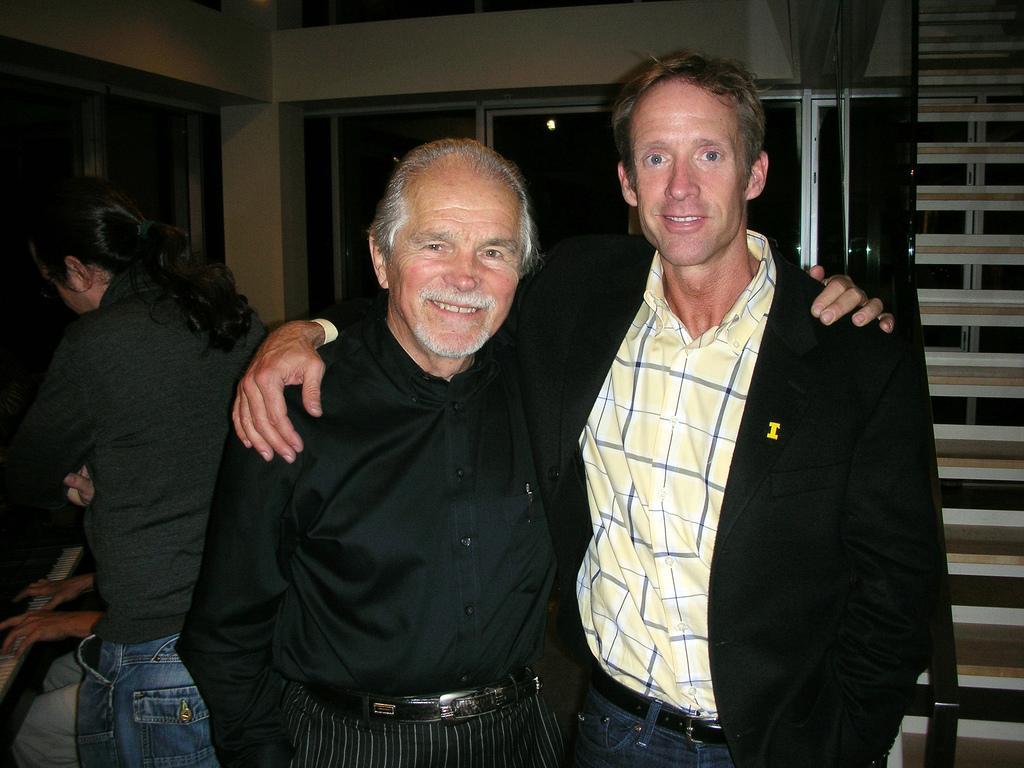Describe this image in one or two sentences. In this image I can see a person wearing black colored dress and another person wearing yellow shirt, black blazer and jeans are standing and smiling. In the background I can see another person standing, the wall, few windows and a person sitting in front of the piano. 